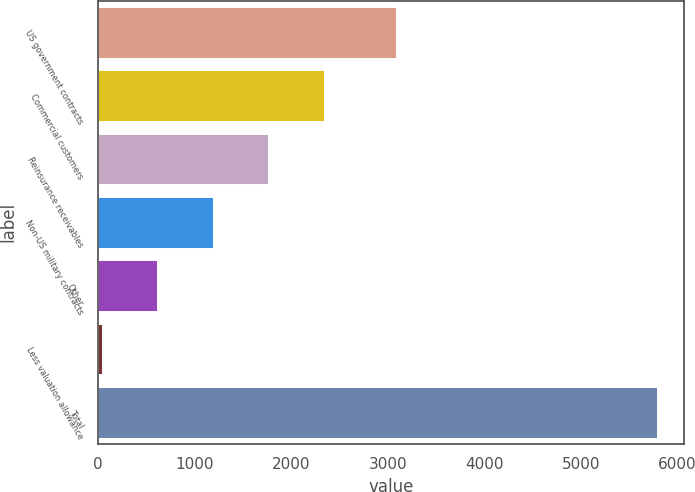<chart> <loc_0><loc_0><loc_500><loc_500><bar_chart><fcel>US government contracts<fcel>Commercial customers<fcel>Reinsurance receivables<fcel>Non-US military contracts<fcel>Other<fcel>Less valuation allowance<fcel>Total<nl><fcel>3090<fcel>2338.6<fcel>1764.2<fcel>1189.8<fcel>615.4<fcel>41<fcel>5785<nl></chart> 